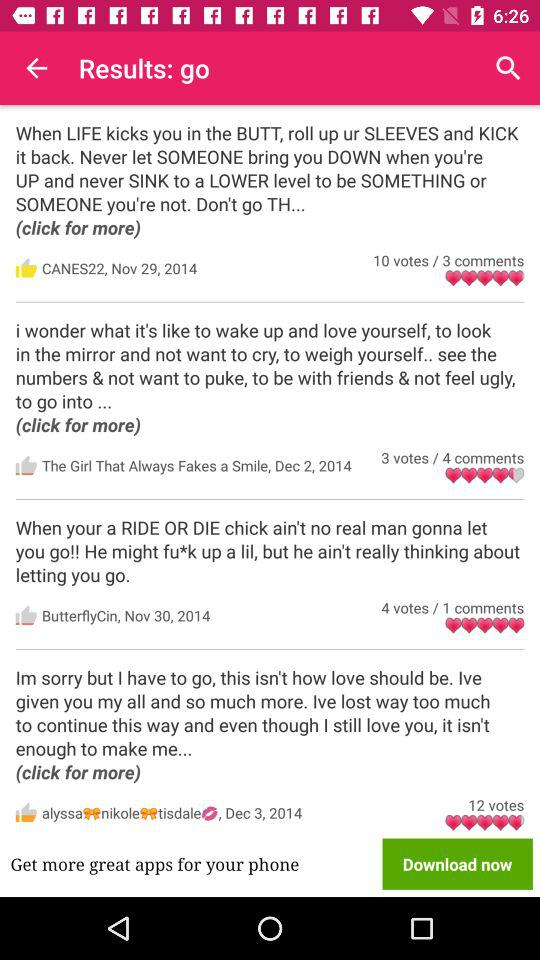When did "CANES22" post the comment? "CANES22" posted the comment on November 29th, 2014. 